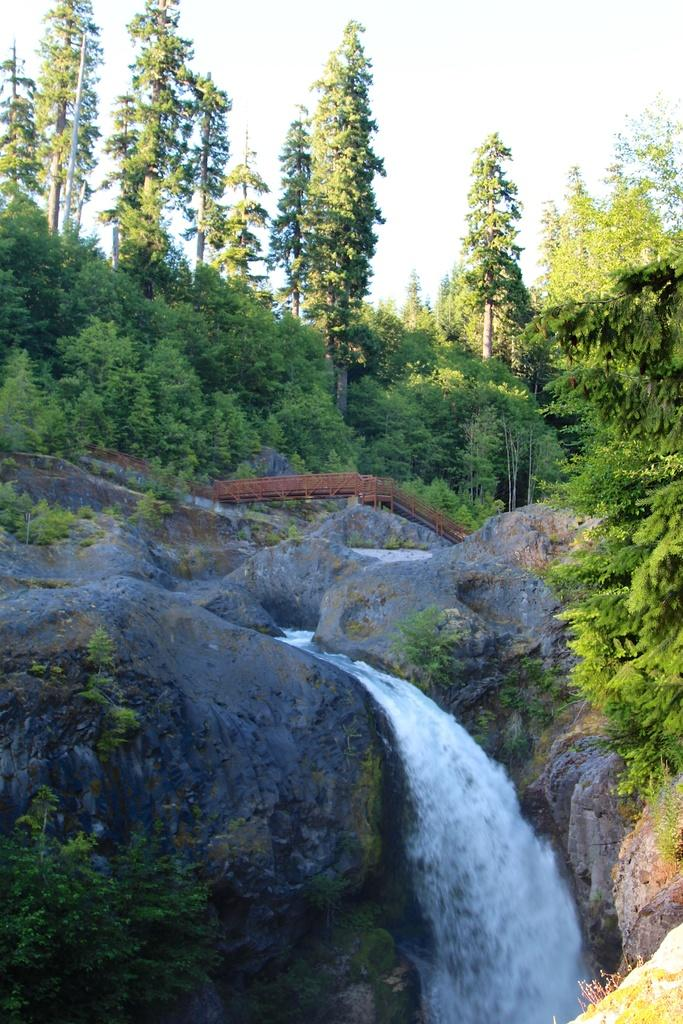What is the main feature in the center of the image? There is a waterfall in the center of the image. What else can be seen in the image besides the waterfall? There are stones and trees visible in the image. What is visible at the top of the image? The sky is visible at the top of the image. How many mice can be seen playing with a bucket in the image? There are no mice or buckets present in the image. Are there any boys visible in the image? There is no mention of boys in the provided facts, and therefore we cannot determine if any are present in the image. 